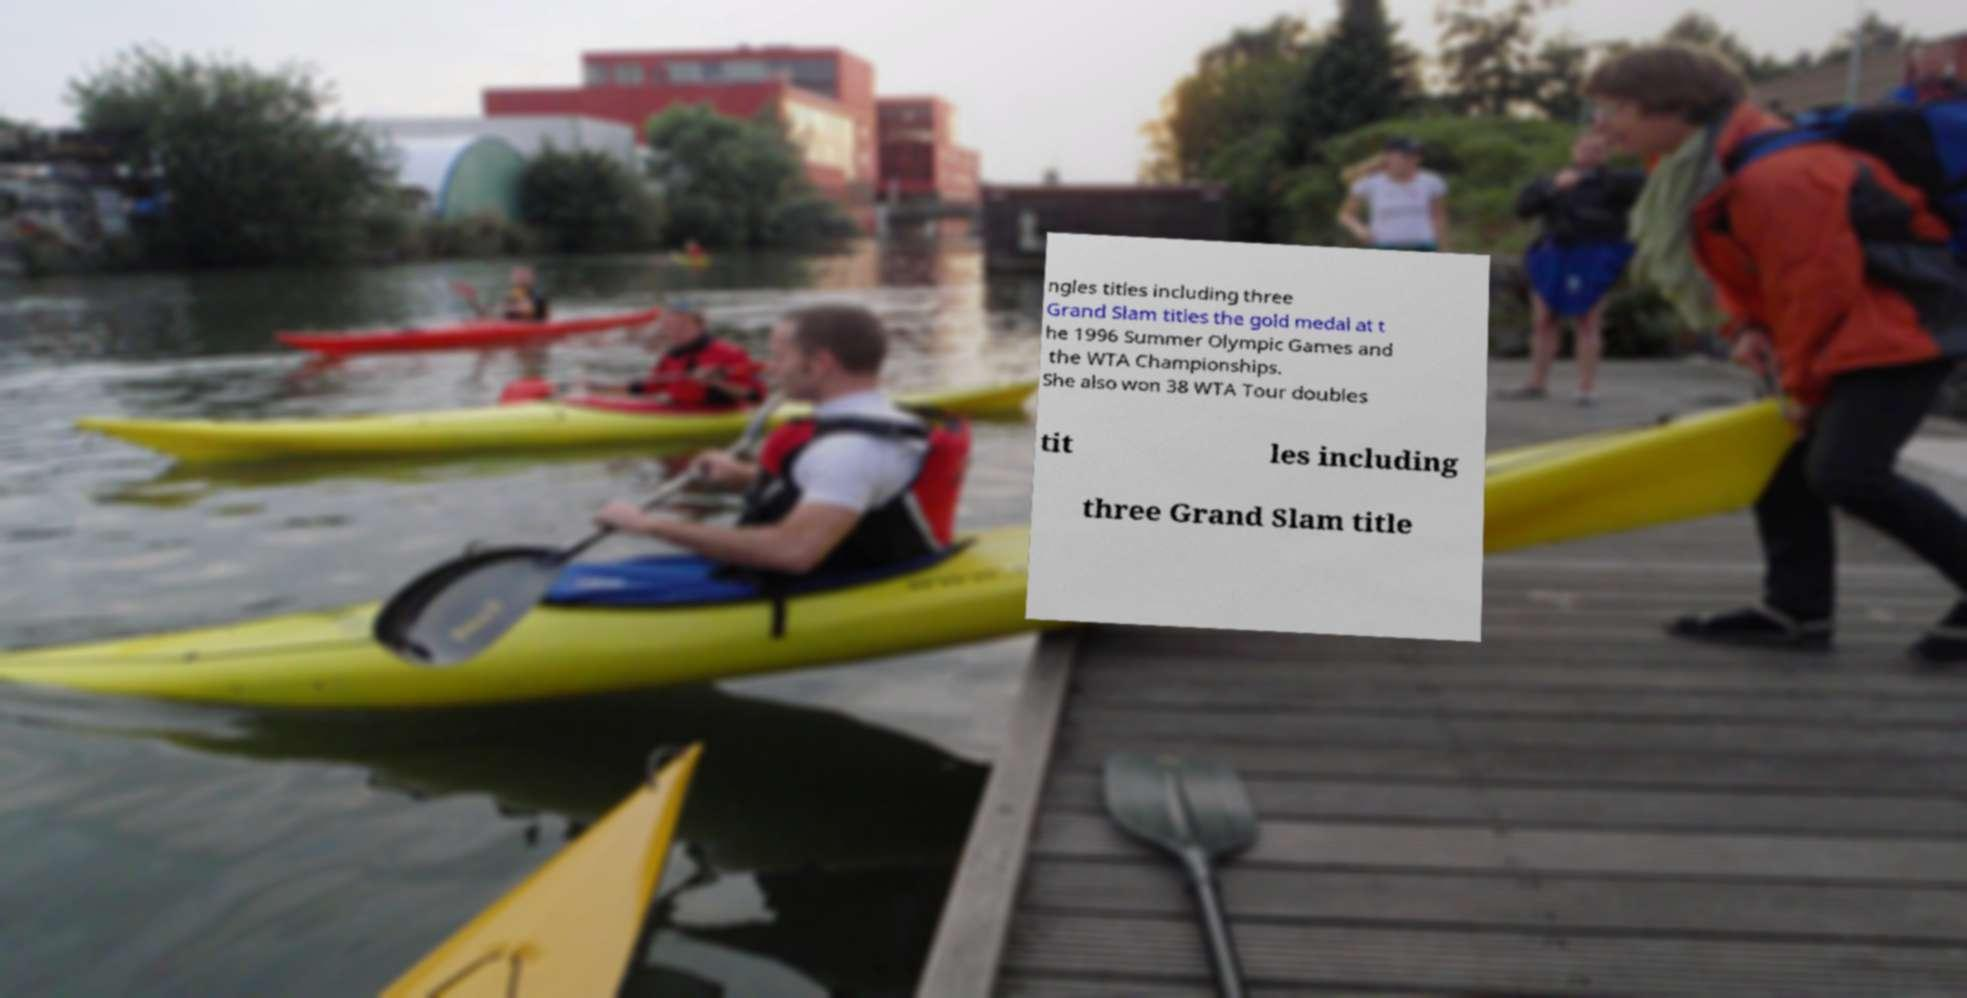I need the written content from this picture converted into text. Can you do that? ngles titles including three Grand Slam titles the gold medal at t he 1996 Summer Olympic Games and the WTA Championships. She also won 38 WTA Tour doubles tit les including three Grand Slam title 